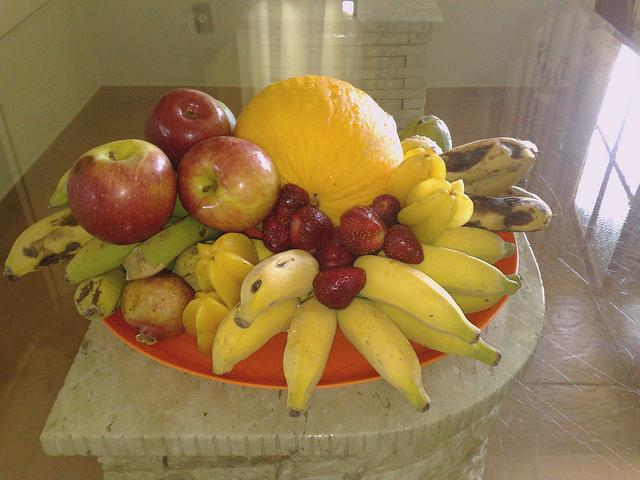What color is the largest fruit on the plate? Please explain your reasoning. yellow. The melon at the center is the largest item in width. 